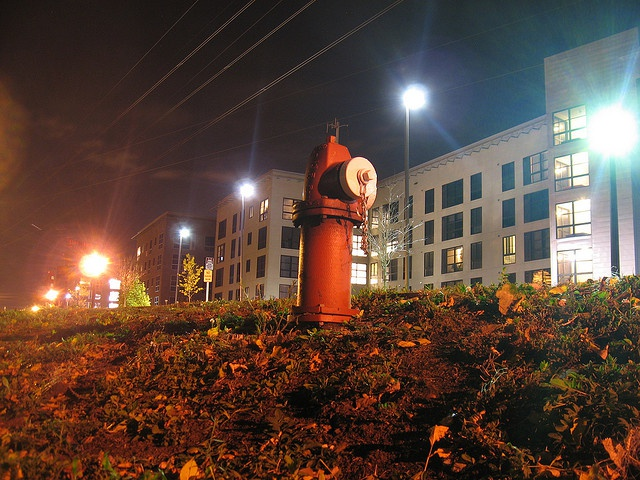Describe the objects in this image and their specific colors. I can see a fire hydrant in black, red, maroon, and brown tones in this image. 